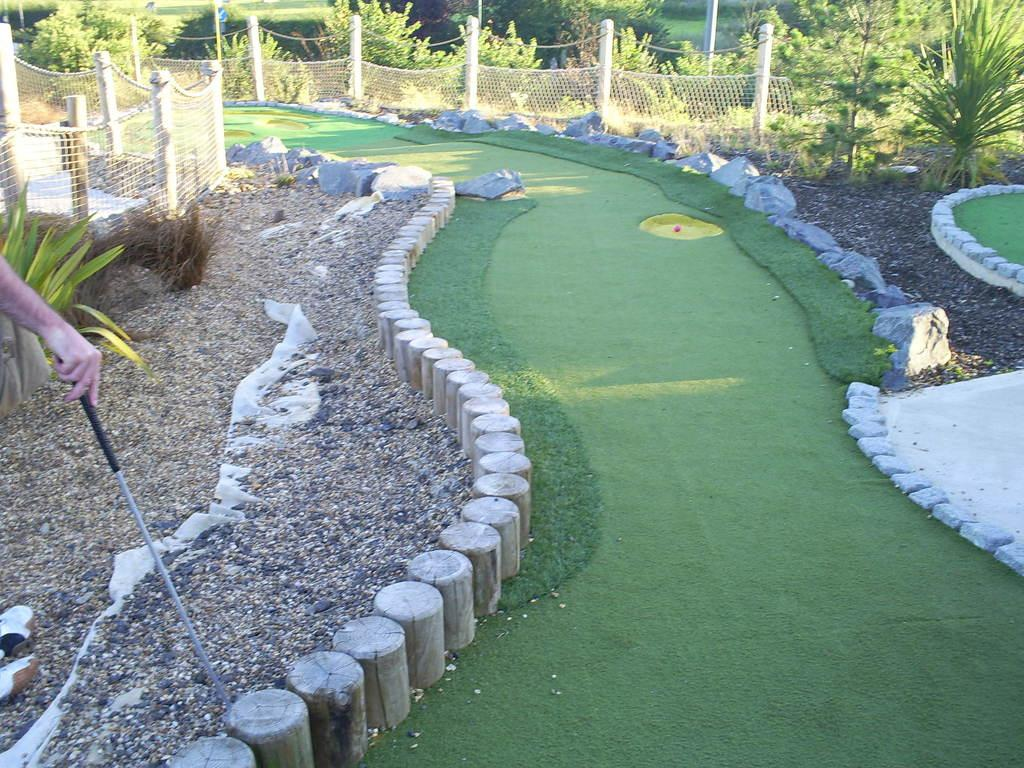What is the person in the image holding? The person is holding a stick in the image. What is in front of the person? There is net fencing in front of the person. What type of vegetation can be seen in the image? There are plants with green color in the image. What structures are visible in the image? There are poles visible in the image. What is the color of the grass in the image? The grass is green in color. Are there any stones present in the image? Yes, stones are present in the image. What theory does the person in the image propose to the manager? There is no manager or theory present in the image; it only shows a person holding a stick with net fencing, plants, poles, stones, and green grass. 